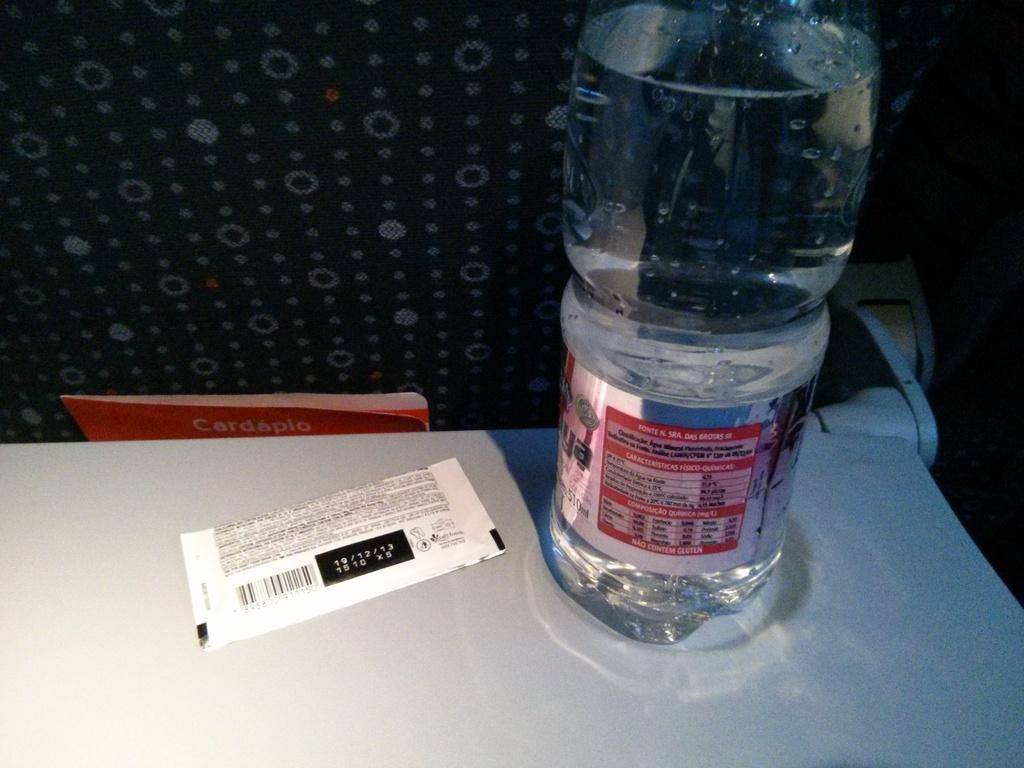<image>
Describe the image concisely. A bottle of water sits next to a wrapper with the date 19/12/13 on it. 